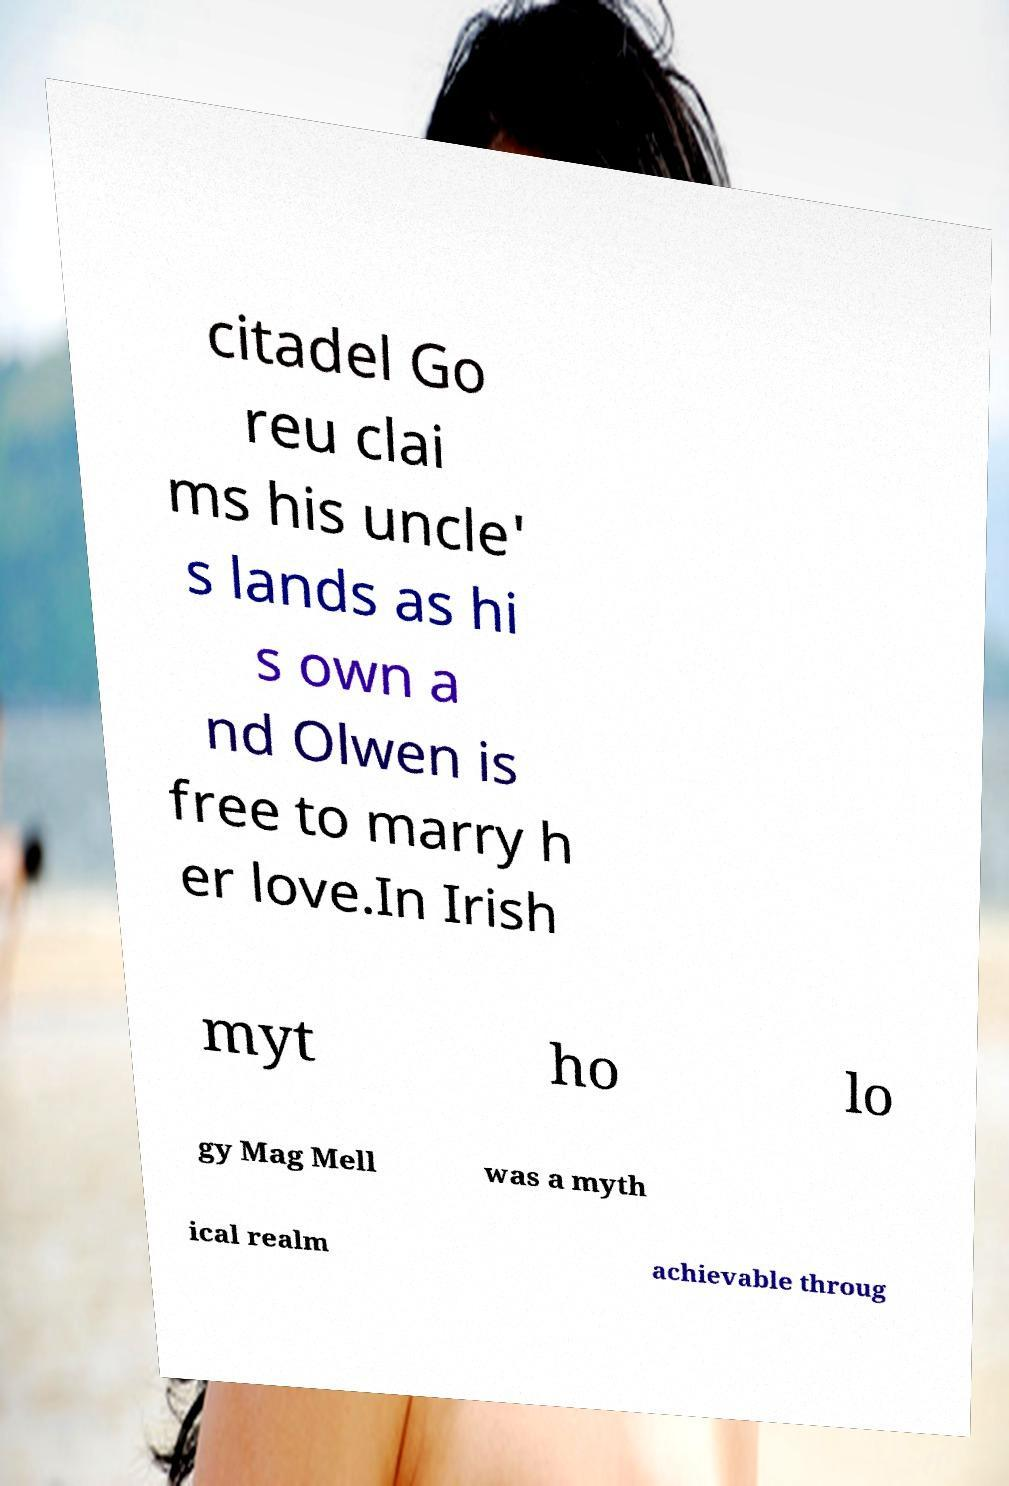Can you accurately transcribe the text from the provided image for me? citadel Go reu clai ms his uncle' s lands as hi s own a nd Olwen is free to marry h er love.In Irish myt ho lo gy Mag Mell was a myth ical realm achievable throug 